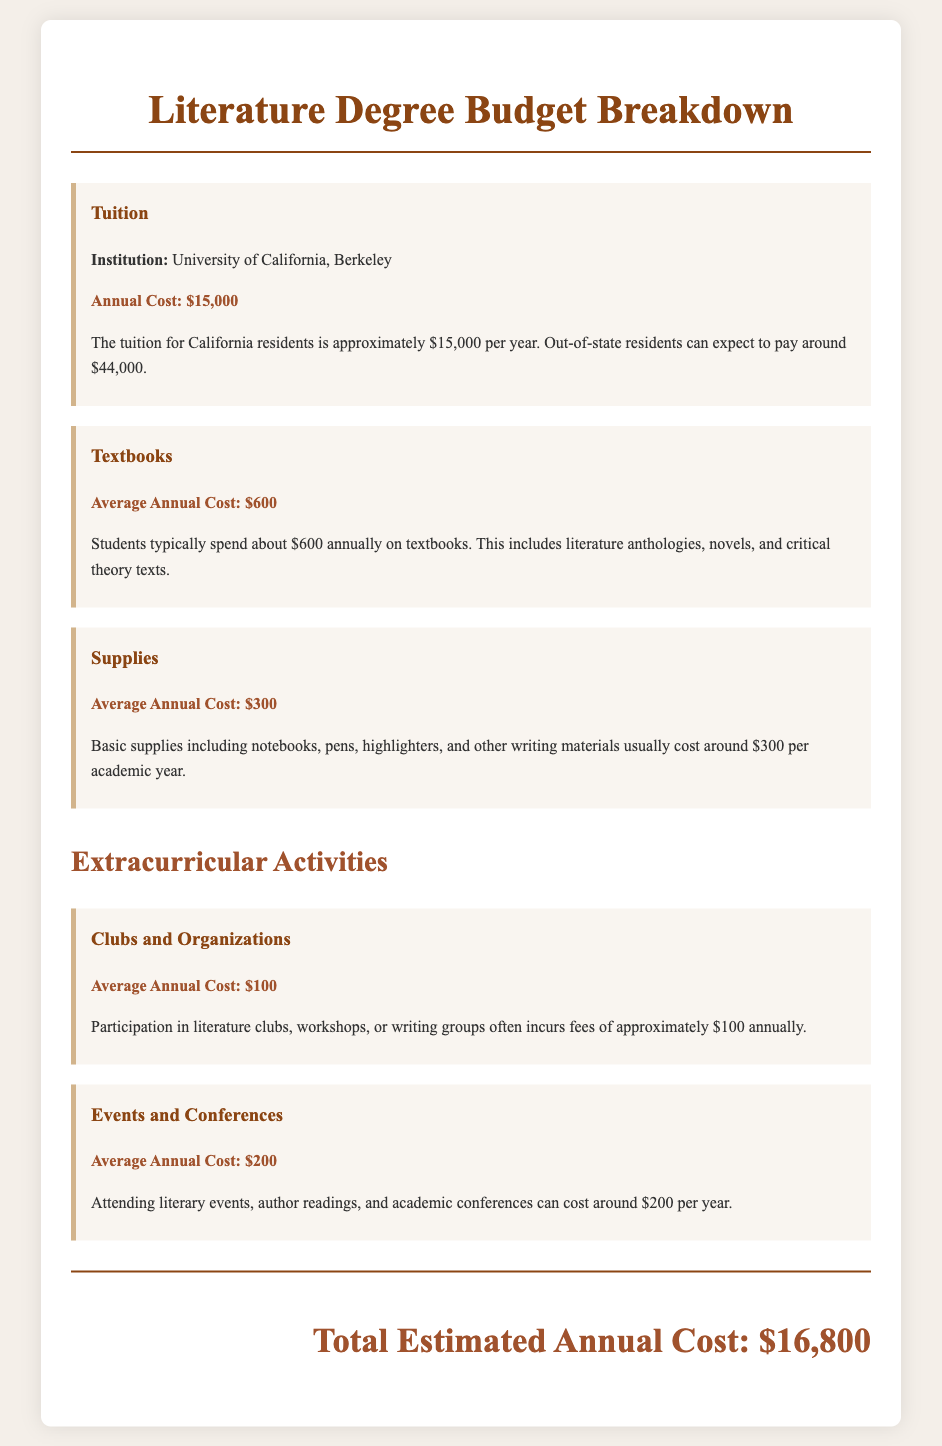What is the annual tuition cost for California residents? The document states that the tuition for California residents is approximately $15,000 per year.
Answer: $15,000 What is the average annual cost for textbooks? The average annual cost for textbooks is stated as $600.
Answer: $600 How much do supplies cost on average annually? Basic supplies cost around $300 per academic year, as noted in the document.
Answer: $300 What is the estimated total annual cost for the literature degree? The document sums up the expenses to a total estimated annual cost of $16,800.
Answer: $16,800 What is the annual cost for participating in clubs and organizations? The document indicates that participation in literature clubs incurs fees of approximately $100 annually.
Answer: $100 How much do students typically spend on events and conferences each year? According to the document, attending literary events and conferences costs around $200 per year.
Answer: $200 What institution is mentioned for tuition costs? The document specifies the institution as the University of California, Berkeley.
Answer: University of California, Berkeley What are the two main categories of expenses listed in the document? The document categorizes expenses into tuition and extracurricular activities.
Answer: Tuition and extracurricular activities 